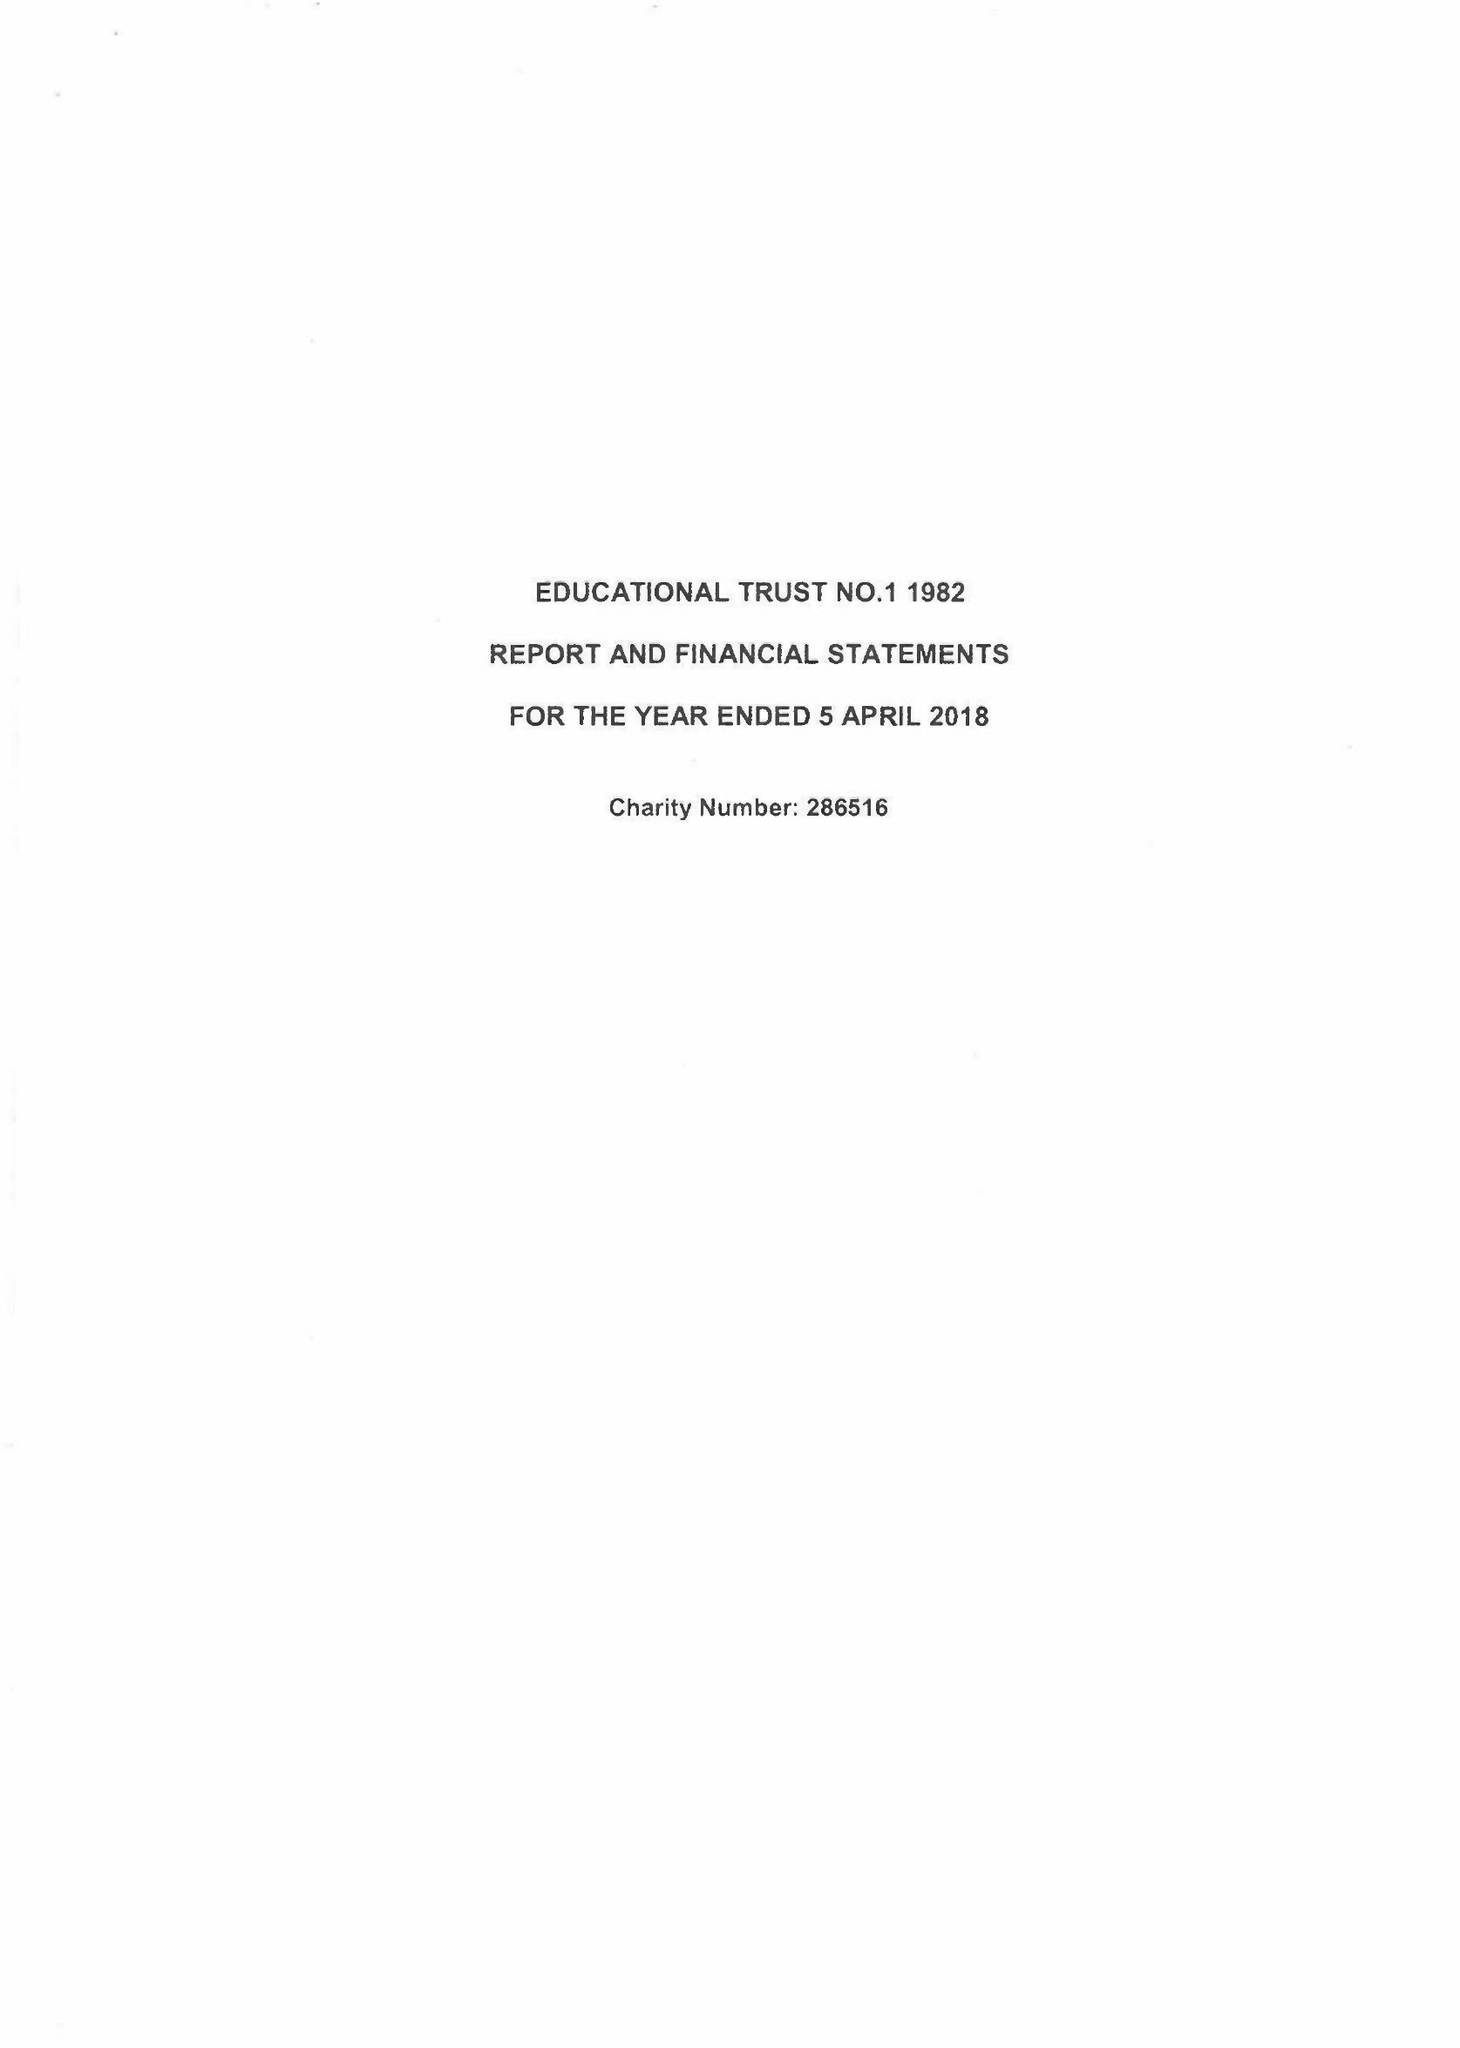What is the value for the address__street_line?
Answer the question using a single word or phrase. THE FORUM PARKWAY 